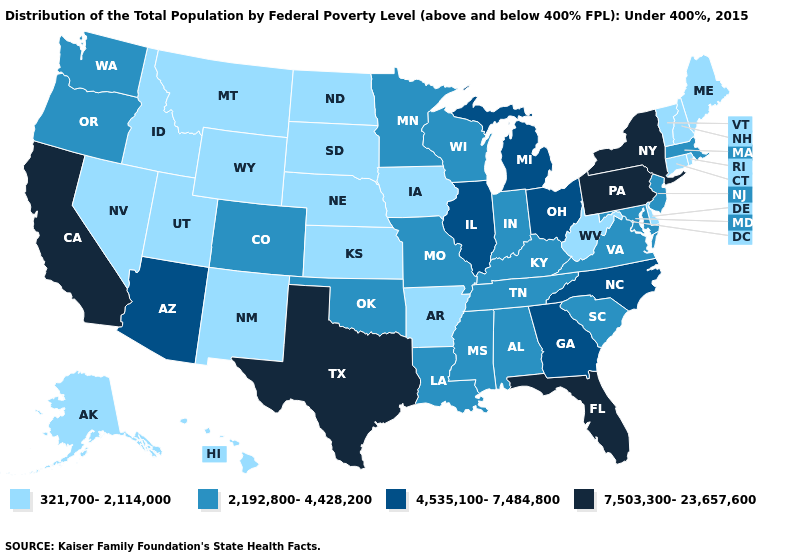Name the states that have a value in the range 4,535,100-7,484,800?
Answer briefly. Arizona, Georgia, Illinois, Michigan, North Carolina, Ohio. Name the states that have a value in the range 2,192,800-4,428,200?
Be succinct. Alabama, Colorado, Indiana, Kentucky, Louisiana, Maryland, Massachusetts, Minnesota, Mississippi, Missouri, New Jersey, Oklahoma, Oregon, South Carolina, Tennessee, Virginia, Washington, Wisconsin. What is the highest value in the USA?
Answer briefly. 7,503,300-23,657,600. What is the highest value in the MidWest ?
Be succinct. 4,535,100-7,484,800. Among the states that border Arizona , which have the highest value?
Quick response, please. California. What is the value of Texas?
Keep it brief. 7,503,300-23,657,600. Which states hav the highest value in the West?
Write a very short answer. California. What is the highest value in the USA?
Write a very short answer. 7,503,300-23,657,600. Name the states that have a value in the range 4,535,100-7,484,800?
Be succinct. Arizona, Georgia, Illinois, Michigan, North Carolina, Ohio. What is the value of Arizona?
Be succinct. 4,535,100-7,484,800. Among the states that border Colorado , which have the lowest value?
Answer briefly. Kansas, Nebraska, New Mexico, Utah, Wyoming. Which states have the lowest value in the Northeast?
Short answer required. Connecticut, Maine, New Hampshire, Rhode Island, Vermont. What is the value of Kansas?
Write a very short answer. 321,700-2,114,000. What is the value of Minnesota?
Short answer required. 2,192,800-4,428,200. Which states have the lowest value in the USA?
Give a very brief answer. Alaska, Arkansas, Connecticut, Delaware, Hawaii, Idaho, Iowa, Kansas, Maine, Montana, Nebraska, Nevada, New Hampshire, New Mexico, North Dakota, Rhode Island, South Dakota, Utah, Vermont, West Virginia, Wyoming. 